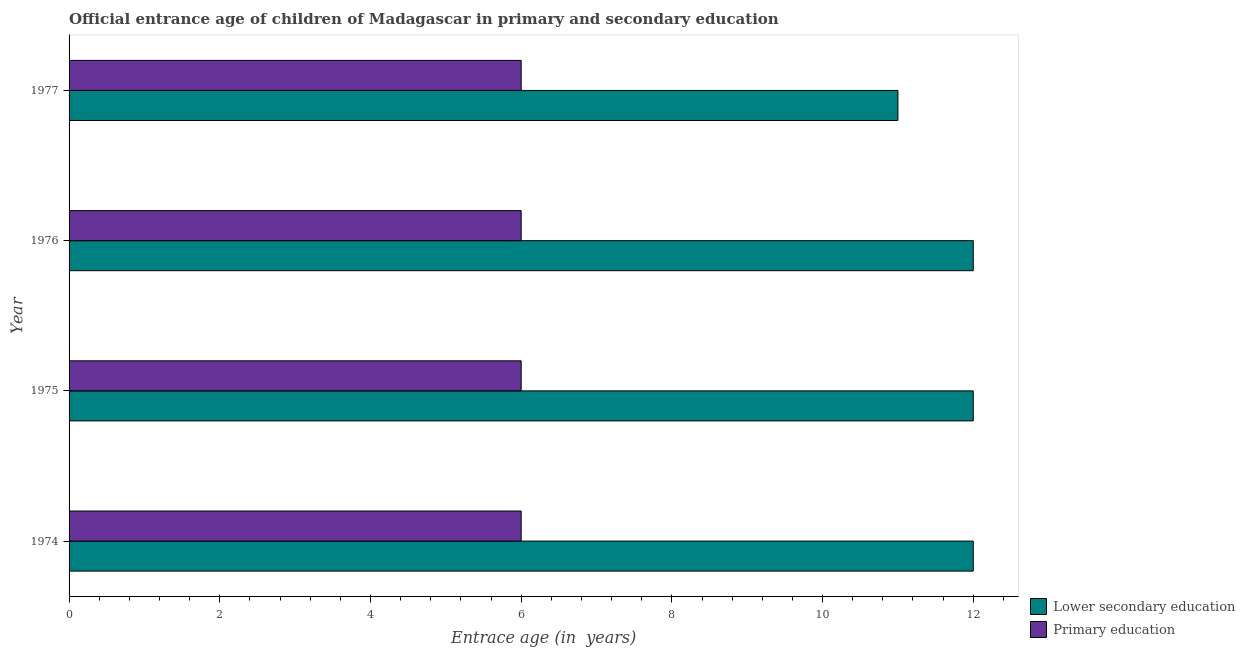How many different coloured bars are there?
Keep it short and to the point. 2. Are the number of bars per tick equal to the number of legend labels?
Make the answer very short. Yes. Are the number of bars on each tick of the Y-axis equal?
Provide a succinct answer. Yes. How many bars are there on the 3rd tick from the top?
Offer a very short reply. 2. What is the label of the 1st group of bars from the top?
Your answer should be very brief. 1977. What is the entrance age of children in lower secondary education in 1974?
Your answer should be compact. 12. Across all years, what is the maximum entrance age of children in lower secondary education?
Ensure brevity in your answer.  12. Across all years, what is the minimum entrance age of chiildren in primary education?
Your answer should be very brief. 6. In which year was the entrance age of chiildren in primary education maximum?
Your answer should be very brief. 1974. In which year was the entrance age of chiildren in primary education minimum?
Offer a very short reply. 1974. What is the total entrance age of children in lower secondary education in the graph?
Your answer should be compact. 47. What is the difference between the entrance age of children in lower secondary education in 1975 and that in 1976?
Offer a very short reply. 0. What is the difference between the entrance age of children in lower secondary education in 1976 and the entrance age of chiildren in primary education in 1977?
Provide a short and direct response. 6. What is the average entrance age of chiildren in primary education per year?
Provide a short and direct response. 6. In the year 1974, what is the difference between the entrance age of chiildren in primary education and entrance age of children in lower secondary education?
Offer a terse response. -6. In how many years, is the entrance age of children in lower secondary education greater than 4.4 years?
Make the answer very short. 4. What is the ratio of the entrance age of children in lower secondary education in 1976 to that in 1977?
Give a very brief answer. 1.09. Is the entrance age of children in lower secondary education in 1974 less than that in 1976?
Offer a terse response. No. Is the difference between the entrance age of children in lower secondary education in 1974 and 1977 greater than the difference between the entrance age of chiildren in primary education in 1974 and 1977?
Give a very brief answer. Yes. What is the difference between the highest and the lowest entrance age of chiildren in primary education?
Make the answer very short. 0. In how many years, is the entrance age of children in lower secondary education greater than the average entrance age of children in lower secondary education taken over all years?
Your response must be concise. 3. What does the 1st bar from the top in 1977 represents?
Your answer should be compact. Primary education. What does the 2nd bar from the bottom in 1976 represents?
Keep it short and to the point. Primary education. How many bars are there?
Keep it short and to the point. 8. Are all the bars in the graph horizontal?
Make the answer very short. Yes. How many years are there in the graph?
Offer a very short reply. 4. What is the difference between two consecutive major ticks on the X-axis?
Your response must be concise. 2. Are the values on the major ticks of X-axis written in scientific E-notation?
Ensure brevity in your answer.  No. How many legend labels are there?
Your answer should be compact. 2. How are the legend labels stacked?
Make the answer very short. Vertical. What is the title of the graph?
Your response must be concise. Official entrance age of children of Madagascar in primary and secondary education. Does "Food" appear as one of the legend labels in the graph?
Your answer should be very brief. No. What is the label or title of the X-axis?
Offer a very short reply. Entrace age (in  years). What is the label or title of the Y-axis?
Your answer should be compact. Year. What is the Entrace age (in  years) of Lower secondary education in 1974?
Your answer should be very brief. 12. What is the Entrace age (in  years) of Lower secondary education in 1975?
Make the answer very short. 12. What is the Entrace age (in  years) in Primary education in 1975?
Make the answer very short. 6. What is the Entrace age (in  years) of Lower secondary education in 1976?
Provide a succinct answer. 12. What is the Entrace age (in  years) in Primary education in 1977?
Provide a short and direct response. 6. Across all years, what is the maximum Entrace age (in  years) in Lower secondary education?
Your answer should be compact. 12. Across all years, what is the minimum Entrace age (in  years) in Lower secondary education?
Offer a terse response. 11. What is the total Entrace age (in  years) in Lower secondary education in the graph?
Offer a very short reply. 47. What is the total Entrace age (in  years) in Primary education in the graph?
Keep it short and to the point. 24. What is the difference between the Entrace age (in  years) of Lower secondary education in 1974 and that in 1976?
Your response must be concise. 0. What is the difference between the Entrace age (in  years) in Primary education in 1975 and that in 1976?
Give a very brief answer. 0. What is the difference between the Entrace age (in  years) in Primary education in 1975 and that in 1977?
Provide a succinct answer. 0. What is the difference between the Entrace age (in  years) of Lower secondary education in 1976 and that in 1977?
Ensure brevity in your answer.  1. What is the difference between the Entrace age (in  years) of Primary education in 1976 and that in 1977?
Provide a short and direct response. 0. What is the difference between the Entrace age (in  years) in Lower secondary education in 1974 and the Entrace age (in  years) in Primary education in 1975?
Make the answer very short. 6. What is the difference between the Entrace age (in  years) in Lower secondary education in 1974 and the Entrace age (in  years) in Primary education in 1976?
Ensure brevity in your answer.  6. What is the difference between the Entrace age (in  years) in Lower secondary education in 1974 and the Entrace age (in  years) in Primary education in 1977?
Offer a very short reply. 6. What is the difference between the Entrace age (in  years) in Lower secondary education in 1975 and the Entrace age (in  years) in Primary education in 1976?
Your answer should be compact. 6. What is the difference between the Entrace age (in  years) in Lower secondary education in 1976 and the Entrace age (in  years) in Primary education in 1977?
Make the answer very short. 6. What is the average Entrace age (in  years) in Lower secondary education per year?
Provide a short and direct response. 11.75. In the year 1975, what is the difference between the Entrace age (in  years) in Lower secondary education and Entrace age (in  years) in Primary education?
Give a very brief answer. 6. In the year 1977, what is the difference between the Entrace age (in  years) of Lower secondary education and Entrace age (in  years) of Primary education?
Keep it short and to the point. 5. What is the ratio of the Entrace age (in  years) of Primary education in 1974 to that in 1975?
Give a very brief answer. 1. What is the ratio of the Entrace age (in  years) in Lower secondary education in 1974 to that in 1977?
Provide a short and direct response. 1.09. What is the ratio of the Entrace age (in  years) in Lower secondary education in 1975 to that in 1976?
Give a very brief answer. 1. What is the ratio of the Entrace age (in  years) of Primary education in 1975 to that in 1976?
Give a very brief answer. 1. What is the ratio of the Entrace age (in  years) in Lower secondary education in 1975 to that in 1977?
Offer a terse response. 1.09. What is the ratio of the Entrace age (in  years) in Primary education in 1975 to that in 1977?
Your answer should be very brief. 1. What is the ratio of the Entrace age (in  years) of Lower secondary education in 1976 to that in 1977?
Your answer should be very brief. 1.09. What is the ratio of the Entrace age (in  years) of Primary education in 1976 to that in 1977?
Provide a short and direct response. 1. What is the difference between the highest and the second highest Entrace age (in  years) of Primary education?
Offer a terse response. 0. What is the difference between the highest and the lowest Entrace age (in  years) of Primary education?
Keep it short and to the point. 0. 